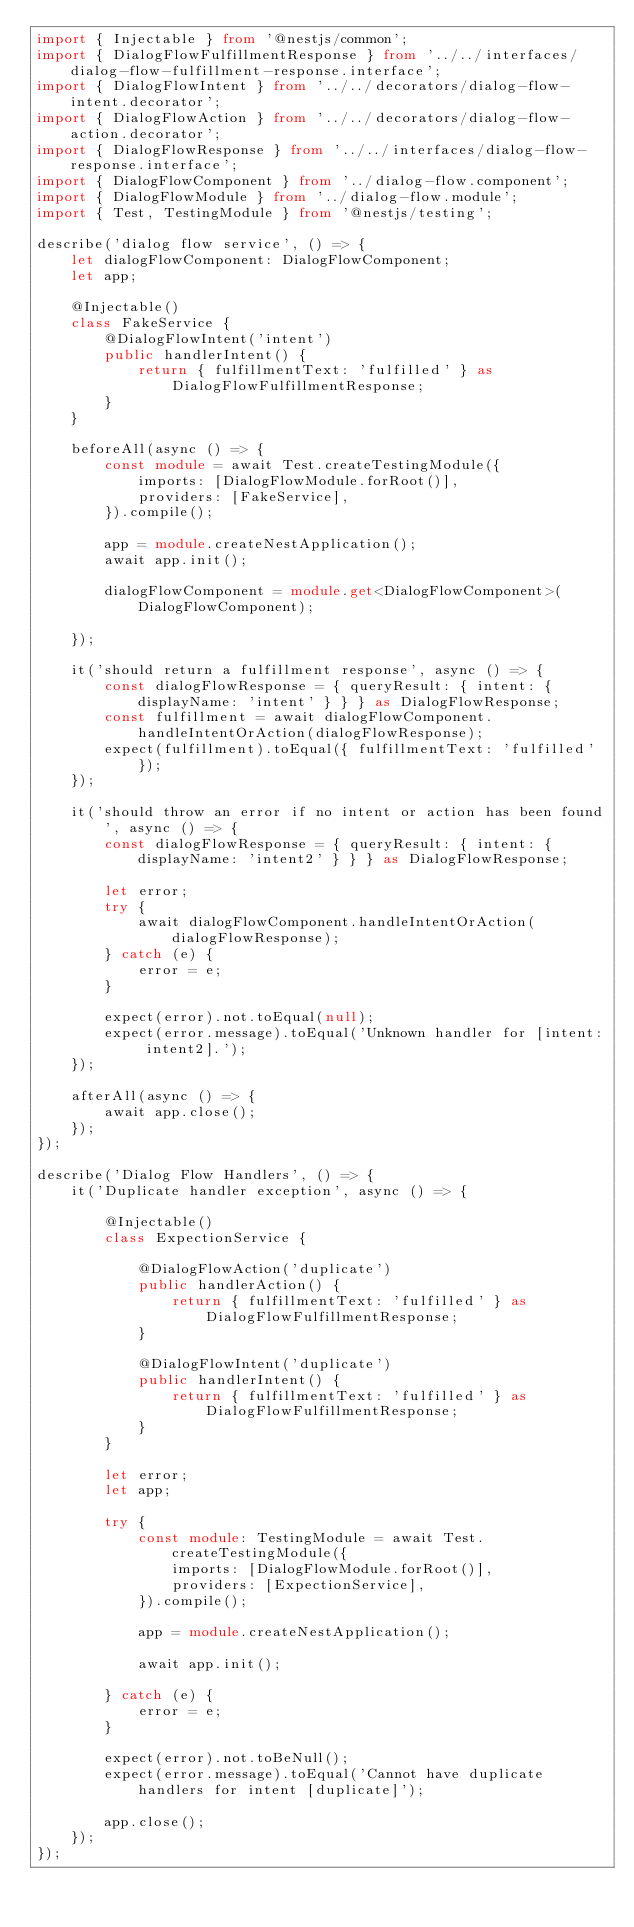<code> <loc_0><loc_0><loc_500><loc_500><_TypeScript_>import { Injectable } from '@nestjs/common';
import { DialogFlowFulfillmentResponse } from '../../interfaces/dialog-flow-fulfillment-response.interface';
import { DialogFlowIntent } from '../../decorators/dialog-flow-intent.decorator';
import { DialogFlowAction } from '../../decorators/dialog-flow-action.decorator';
import { DialogFlowResponse } from '../../interfaces/dialog-flow-response.interface';
import { DialogFlowComponent } from '../dialog-flow.component';
import { DialogFlowModule } from '../dialog-flow.module';
import { Test, TestingModule } from '@nestjs/testing';

describe('dialog flow service', () => {
    let dialogFlowComponent: DialogFlowComponent;
    let app;

    @Injectable()
    class FakeService {
        @DialogFlowIntent('intent')
        public handlerIntent() {
            return { fulfillmentText: 'fulfilled' } as DialogFlowFulfillmentResponse;
        }
    }

    beforeAll(async () => {
        const module = await Test.createTestingModule({
            imports: [DialogFlowModule.forRoot()],
            providers: [FakeService],
        }).compile();

        app = module.createNestApplication();
        await app.init();

        dialogFlowComponent = module.get<DialogFlowComponent>(DialogFlowComponent);

    });

    it('should return a fulfillment response', async () => {
        const dialogFlowResponse = { queryResult: { intent: { displayName: 'intent' } } } as DialogFlowResponse;
        const fulfillment = await dialogFlowComponent.handleIntentOrAction(dialogFlowResponse);
        expect(fulfillment).toEqual({ fulfillmentText: 'fulfilled' });
    });

    it('should throw an error if no intent or action has been found', async () => {
        const dialogFlowResponse = { queryResult: { intent: { displayName: 'intent2' } } } as DialogFlowResponse;

        let error;
        try {
            await dialogFlowComponent.handleIntentOrAction(dialogFlowResponse);
        } catch (e) {
            error = e;
        }

        expect(error).not.toEqual(null);
        expect(error.message).toEqual('Unknown handler for [intent: intent2].');
    });

    afterAll(async () => {
        await app.close();
    });
});

describe('Dialog Flow Handlers', () => {
    it('Duplicate handler exception', async () => {

        @Injectable()
        class ExpectionService {

            @DialogFlowAction('duplicate')
            public handlerAction() {
                return { fulfillmentText: 'fulfilled' } as DialogFlowFulfillmentResponse;
            }

            @DialogFlowIntent('duplicate')
            public handlerIntent() {
                return { fulfillmentText: 'fulfilled' } as DialogFlowFulfillmentResponse;
            }
        }

        let error;
        let app;

        try {
            const module: TestingModule = await Test.createTestingModule({
                imports: [DialogFlowModule.forRoot()],
                providers: [ExpectionService],
            }).compile();

            app = module.createNestApplication();

            await app.init();

        } catch (e) {
            error = e;
        }

        expect(error).not.toBeNull();
        expect(error.message).toEqual('Cannot have duplicate handlers for intent [duplicate]');

        app.close();
    });
});
</code> 